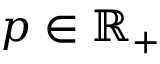<formula> <loc_0><loc_0><loc_500><loc_500>p \in \mathbb { R } _ { + }</formula> 